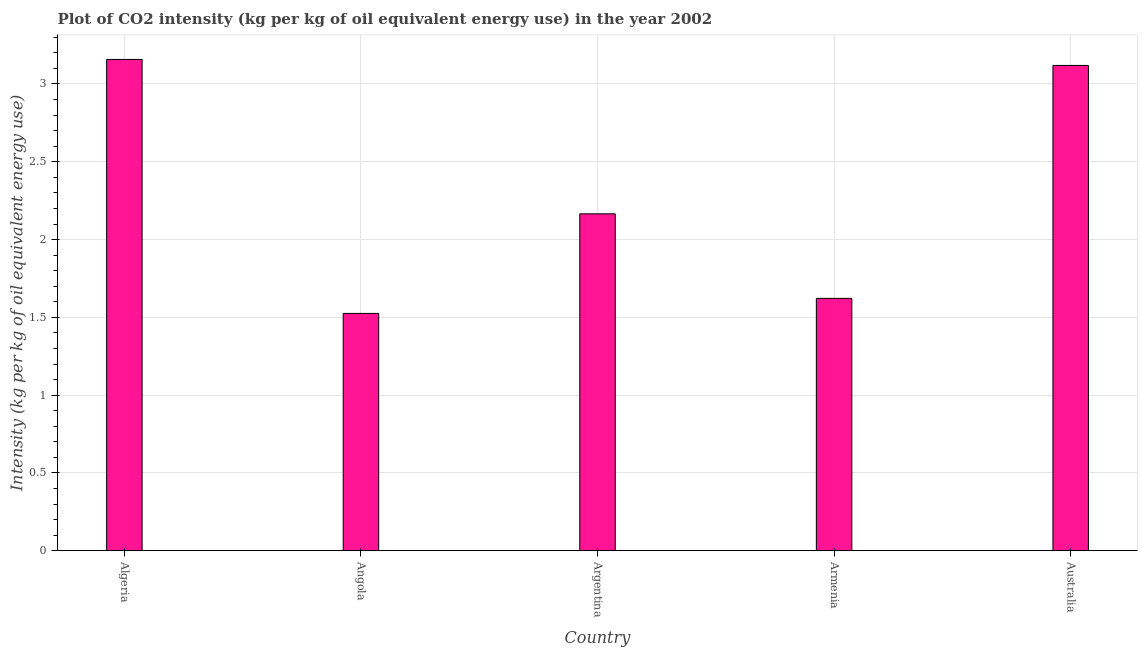Does the graph contain grids?
Your answer should be very brief. Yes. What is the title of the graph?
Provide a short and direct response. Plot of CO2 intensity (kg per kg of oil equivalent energy use) in the year 2002. What is the label or title of the X-axis?
Make the answer very short. Country. What is the label or title of the Y-axis?
Offer a terse response. Intensity (kg per kg of oil equivalent energy use). What is the co2 intensity in Argentina?
Give a very brief answer. 2.17. Across all countries, what is the maximum co2 intensity?
Your answer should be very brief. 3.16. Across all countries, what is the minimum co2 intensity?
Ensure brevity in your answer.  1.53. In which country was the co2 intensity maximum?
Your response must be concise. Algeria. In which country was the co2 intensity minimum?
Keep it short and to the point. Angola. What is the sum of the co2 intensity?
Ensure brevity in your answer.  11.59. What is the difference between the co2 intensity in Angola and Armenia?
Keep it short and to the point. -0.1. What is the average co2 intensity per country?
Provide a short and direct response. 2.32. What is the median co2 intensity?
Keep it short and to the point. 2.17. In how many countries, is the co2 intensity greater than 2.7 kg?
Offer a very short reply. 2. What is the ratio of the co2 intensity in Argentina to that in Australia?
Make the answer very short. 0.69. Is the co2 intensity in Argentina less than that in Australia?
Ensure brevity in your answer.  Yes. Is the difference between the co2 intensity in Algeria and Angola greater than the difference between any two countries?
Offer a terse response. Yes. What is the difference between the highest and the second highest co2 intensity?
Provide a succinct answer. 0.04. Is the sum of the co2 intensity in Angola and Argentina greater than the maximum co2 intensity across all countries?
Your answer should be very brief. Yes. What is the difference between the highest and the lowest co2 intensity?
Provide a succinct answer. 1.63. How many countries are there in the graph?
Your answer should be compact. 5. What is the Intensity (kg per kg of oil equivalent energy use) in Algeria?
Keep it short and to the point. 3.16. What is the Intensity (kg per kg of oil equivalent energy use) in Angola?
Your answer should be compact. 1.53. What is the Intensity (kg per kg of oil equivalent energy use) in Argentina?
Make the answer very short. 2.17. What is the Intensity (kg per kg of oil equivalent energy use) in Armenia?
Give a very brief answer. 1.62. What is the Intensity (kg per kg of oil equivalent energy use) of Australia?
Offer a very short reply. 3.12. What is the difference between the Intensity (kg per kg of oil equivalent energy use) in Algeria and Angola?
Offer a terse response. 1.63. What is the difference between the Intensity (kg per kg of oil equivalent energy use) in Algeria and Argentina?
Offer a very short reply. 0.99. What is the difference between the Intensity (kg per kg of oil equivalent energy use) in Algeria and Armenia?
Your answer should be very brief. 1.54. What is the difference between the Intensity (kg per kg of oil equivalent energy use) in Algeria and Australia?
Give a very brief answer. 0.04. What is the difference between the Intensity (kg per kg of oil equivalent energy use) in Angola and Argentina?
Your answer should be very brief. -0.64. What is the difference between the Intensity (kg per kg of oil equivalent energy use) in Angola and Armenia?
Provide a short and direct response. -0.1. What is the difference between the Intensity (kg per kg of oil equivalent energy use) in Angola and Australia?
Offer a very short reply. -1.59. What is the difference between the Intensity (kg per kg of oil equivalent energy use) in Argentina and Armenia?
Provide a short and direct response. 0.54. What is the difference between the Intensity (kg per kg of oil equivalent energy use) in Argentina and Australia?
Provide a short and direct response. -0.95. What is the difference between the Intensity (kg per kg of oil equivalent energy use) in Armenia and Australia?
Your answer should be compact. -1.5. What is the ratio of the Intensity (kg per kg of oil equivalent energy use) in Algeria to that in Angola?
Give a very brief answer. 2.07. What is the ratio of the Intensity (kg per kg of oil equivalent energy use) in Algeria to that in Argentina?
Offer a terse response. 1.46. What is the ratio of the Intensity (kg per kg of oil equivalent energy use) in Algeria to that in Armenia?
Your response must be concise. 1.95. What is the ratio of the Intensity (kg per kg of oil equivalent energy use) in Algeria to that in Australia?
Your answer should be very brief. 1.01. What is the ratio of the Intensity (kg per kg of oil equivalent energy use) in Angola to that in Argentina?
Ensure brevity in your answer.  0.7. What is the ratio of the Intensity (kg per kg of oil equivalent energy use) in Angola to that in Australia?
Your answer should be compact. 0.49. What is the ratio of the Intensity (kg per kg of oil equivalent energy use) in Argentina to that in Armenia?
Ensure brevity in your answer.  1.33. What is the ratio of the Intensity (kg per kg of oil equivalent energy use) in Argentina to that in Australia?
Give a very brief answer. 0.69. What is the ratio of the Intensity (kg per kg of oil equivalent energy use) in Armenia to that in Australia?
Provide a succinct answer. 0.52. 